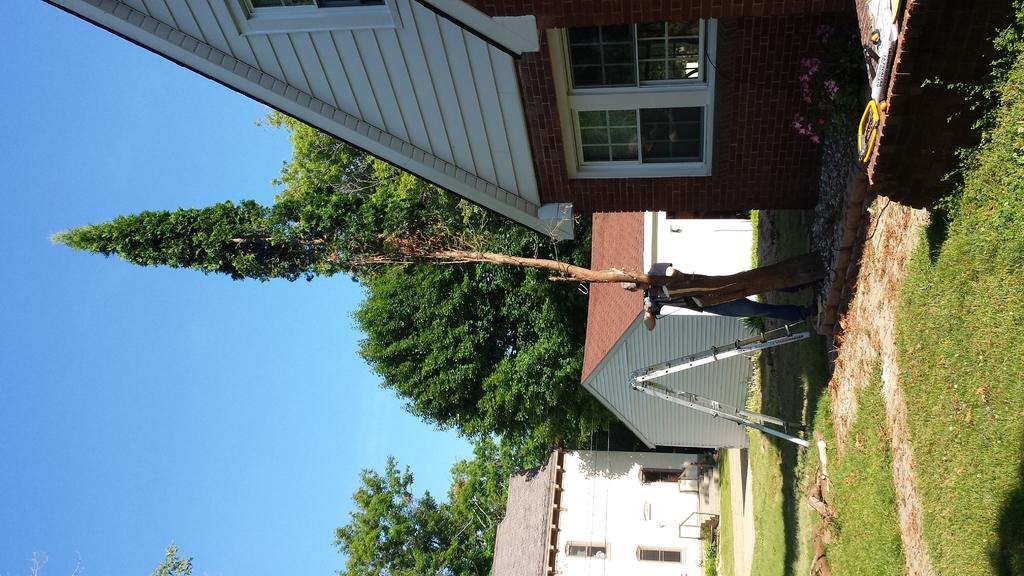What type of structures are located at the bottom of the image? There are houses at the bottom of the image. What can be seen in the image besides the houses? There is a stand, a person, trees, and the sky visible on the left side of the image. Where is the house located in relation to the other elements in the image? There is a house at the top of the image. What type of roof can be seen on the trees in the image? There are no roofs on the trees in the image, as trees do not have roofs. How many pages are visible in the image? There are no pages present in the image. 